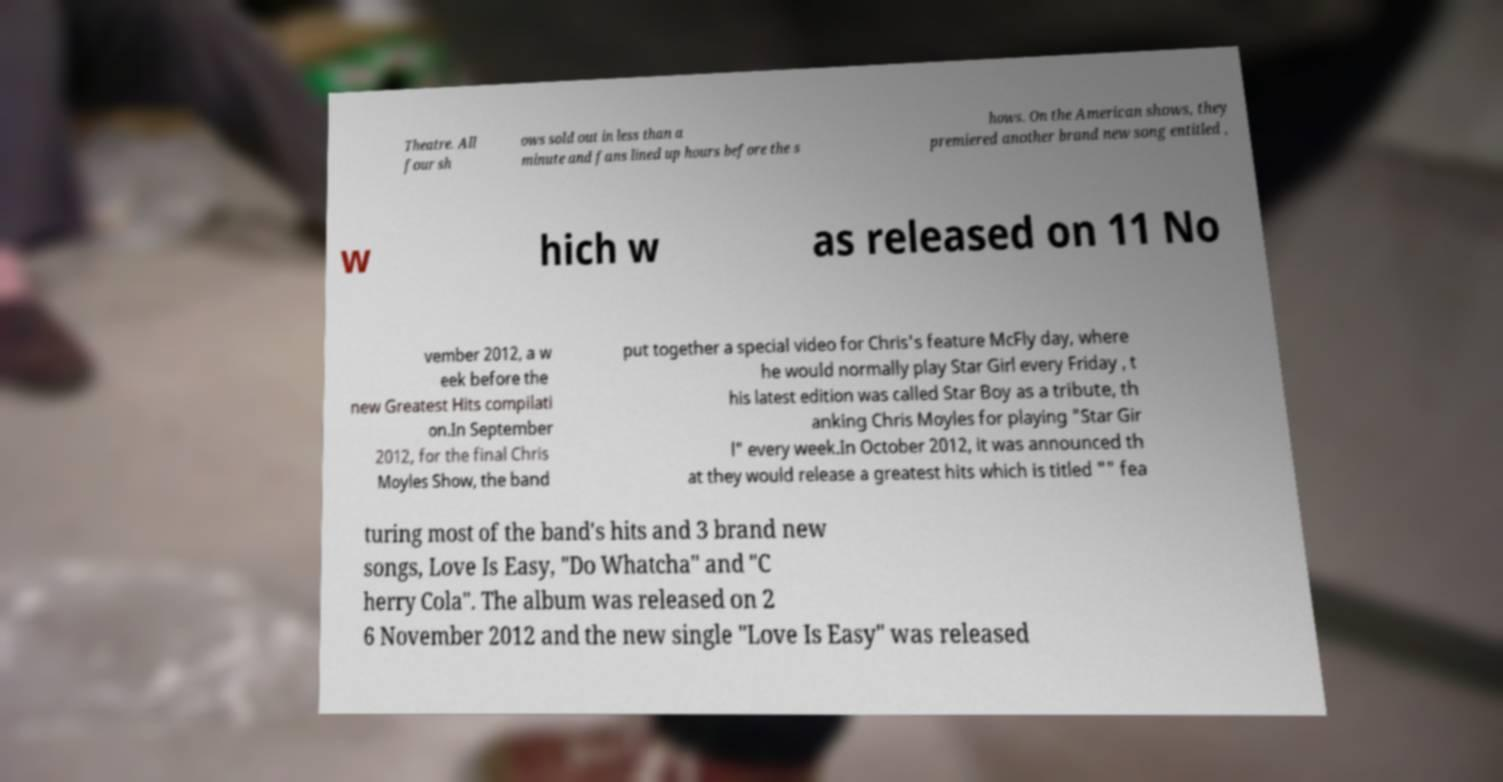For documentation purposes, I need the text within this image transcribed. Could you provide that? Theatre. All four sh ows sold out in less than a minute and fans lined up hours before the s hows. On the American shows, they premiered another brand new song entitled , w hich w as released on 11 No vember 2012, a w eek before the new Greatest Hits compilati on.In September 2012, for the final Chris Moyles Show, the band put together a special video for Chris's feature McFly day, where he would normally play Star Girl every Friday , t his latest edition was called Star Boy as a tribute, th anking Chris Moyles for playing "Star Gir l" every week.In October 2012, it was announced th at they would release a greatest hits which is titled "" fea turing most of the band's hits and 3 brand new songs, Love Is Easy, "Do Whatcha" and "C herry Cola". The album was released on 2 6 November 2012 and the new single "Love Is Easy" was released 